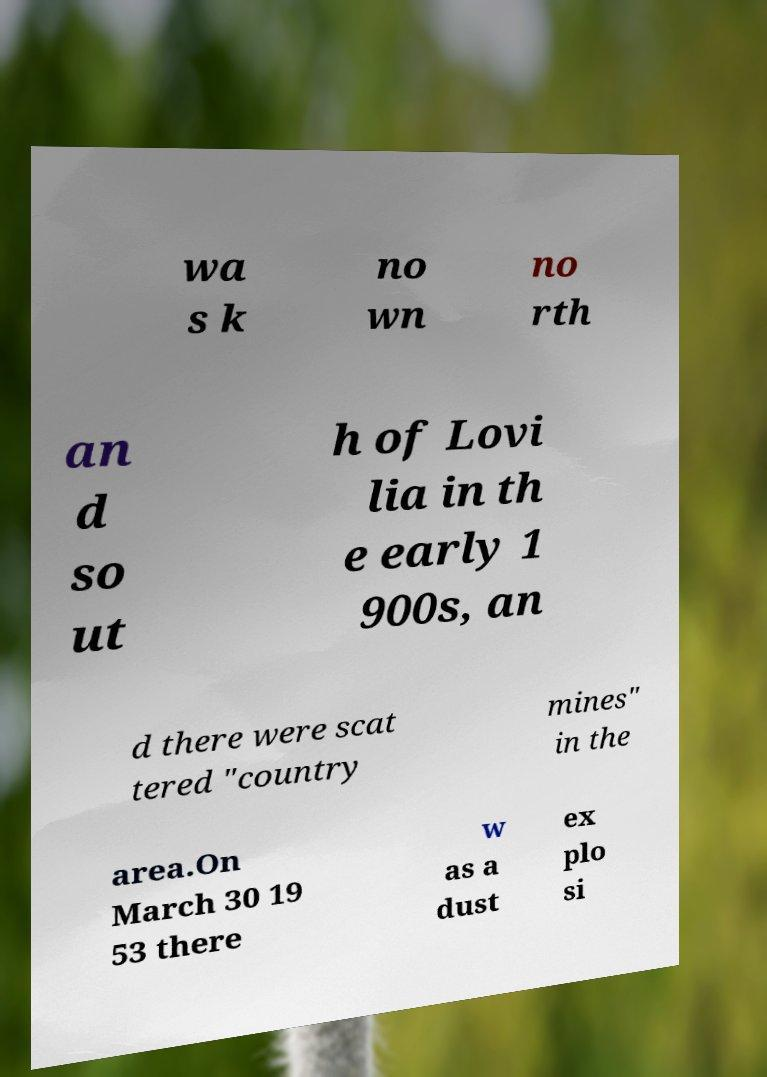Please read and relay the text visible in this image. What does it say? wa s k no wn no rth an d so ut h of Lovi lia in th e early 1 900s, an d there were scat tered "country mines" in the area.On March 30 19 53 there w as a dust ex plo si 